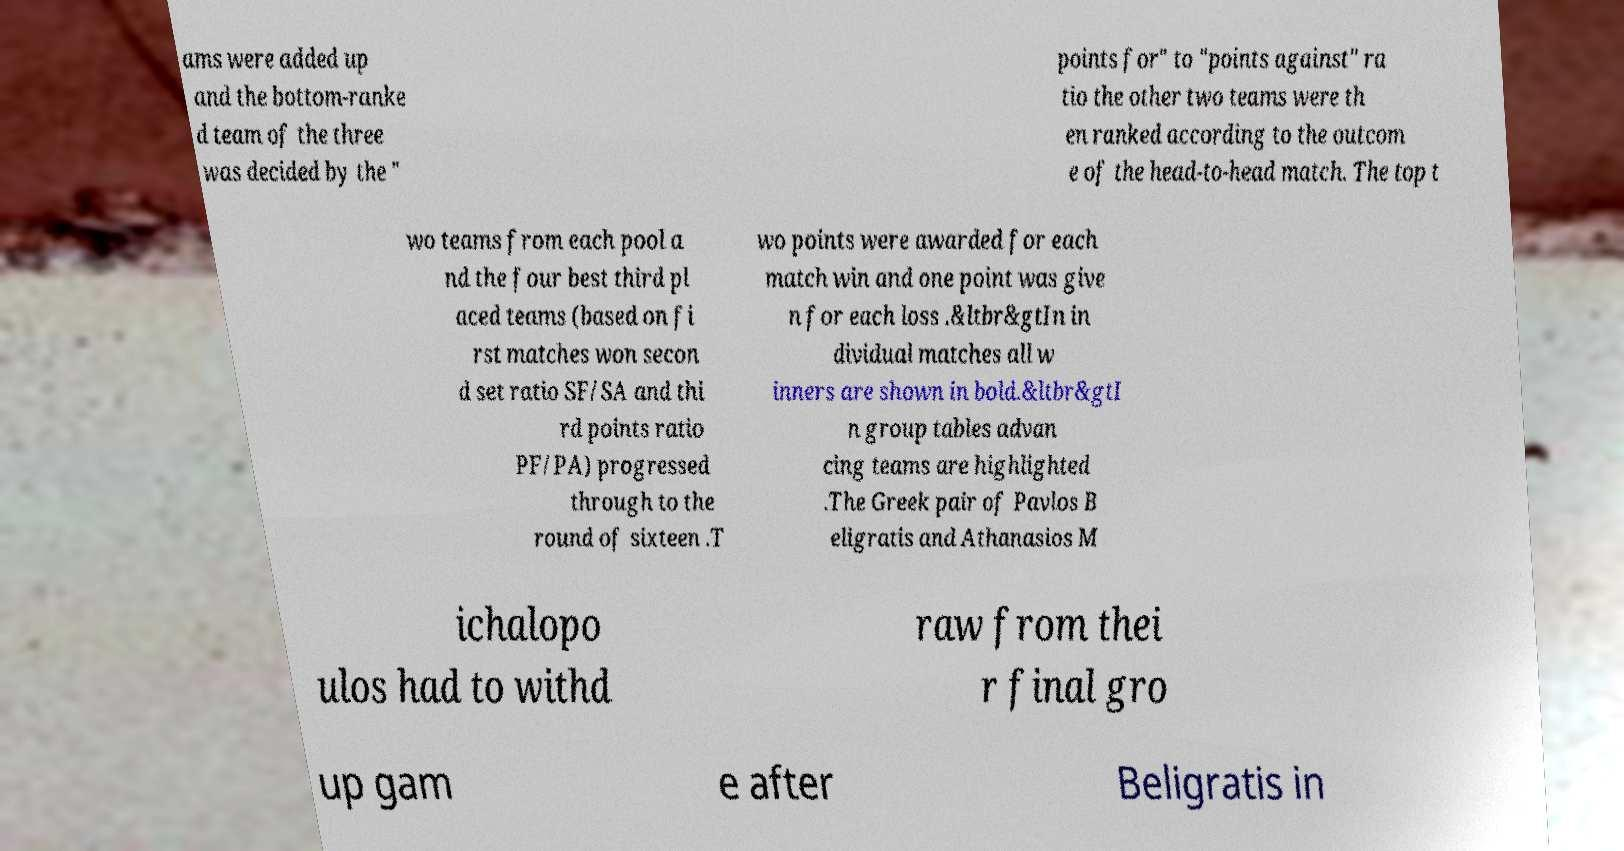Could you assist in decoding the text presented in this image and type it out clearly? ams were added up and the bottom-ranke d team of the three was decided by the " points for" to "points against" ra tio the other two teams were th en ranked according to the outcom e of the head-to-head match. The top t wo teams from each pool a nd the four best third pl aced teams (based on fi rst matches won secon d set ratio SF/SA and thi rd points ratio PF/PA) progressed through to the round of sixteen .T wo points were awarded for each match win and one point was give n for each loss .&ltbr&gtIn in dividual matches all w inners are shown in bold.&ltbr&gtI n group tables advan cing teams are highlighted .The Greek pair of Pavlos B eligratis and Athanasios M ichalopo ulos had to withd raw from thei r final gro up gam e after Beligratis in 